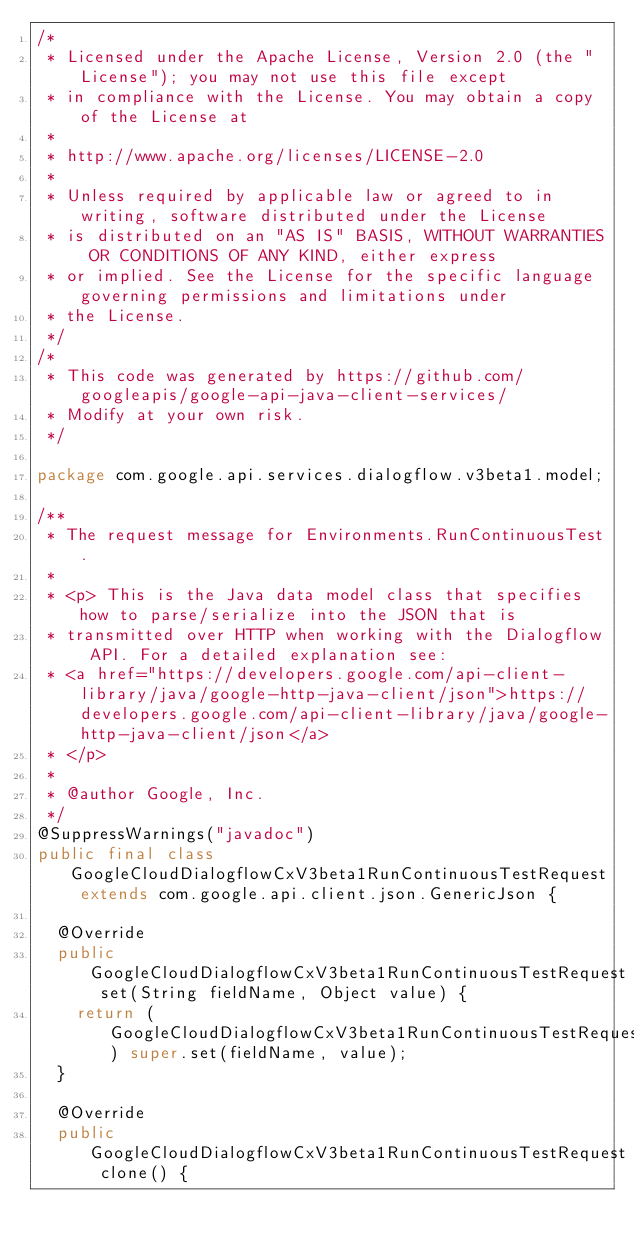<code> <loc_0><loc_0><loc_500><loc_500><_Java_>/*
 * Licensed under the Apache License, Version 2.0 (the "License"); you may not use this file except
 * in compliance with the License. You may obtain a copy of the License at
 *
 * http://www.apache.org/licenses/LICENSE-2.0
 *
 * Unless required by applicable law or agreed to in writing, software distributed under the License
 * is distributed on an "AS IS" BASIS, WITHOUT WARRANTIES OR CONDITIONS OF ANY KIND, either express
 * or implied. See the License for the specific language governing permissions and limitations under
 * the License.
 */
/*
 * This code was generated by https://github.com/googleapis/google-api-java-client-services/
 * Modify at your own risk.
 */

package com.google.api.services.dialogflow.v3beta1.model;

/**
 * The request message for Environments.RunContinuousTest.
 *
 * <p> This is the Java data model class that specifies how to parse/serialize into the JSON that is
 * transmitted over HTTP when working with the Dialogflow API. For a detailed explanation see:
 * <a href="https://developers.google.com/api-client-library/java/google-http-java-client/json">https://developers.google.com/api-client-library/java/google-http-java-client/json</a>
 * </p>
 *
 * @author Google, Inc.
 */
@SuppressWarnings("javadoc")
public final class GoogleCloudDialogflowCxV3beta1RunContinuousTestRequest extends com.google.api.client.json.GenericJson {

  @Override
  public GoogleCloudDialogflowCxV3beta1RunContinuousTestRequest set(String fieldName, Object value) {
    return (GoogleCloudDialogflowCxV3beta1RunContinuousTestRequest) super.set(fieldName, value);
  }

  @Override
  public GoogleCloudDialogflowCxV3beta1RunContinuousTestRequest clone() {</code> 